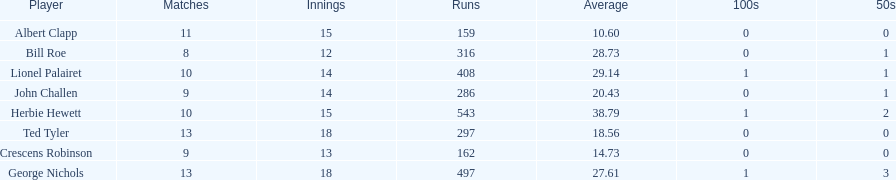How many runs did ted tyler have? 297. 